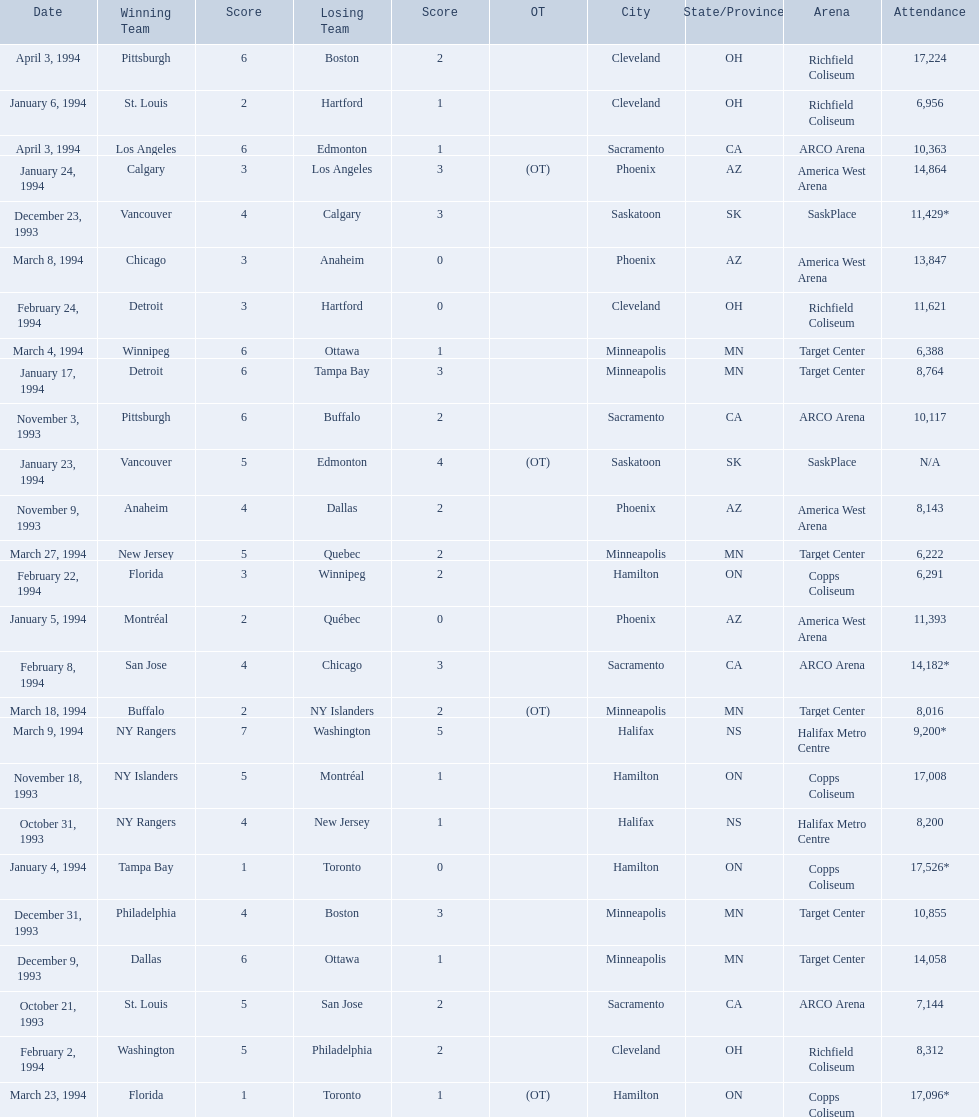What was the attendance on january 24, 1994? 14,864. What was the attendance on december 23, 1993? 11,429*. Between january 24, 1994 and december 23, 1993, which had the higher attendance? January 4, 1994. 